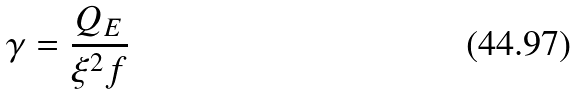Convert formula to latex. <formula><loc_0><loc_0><loc_500><loc_500>\gamma = \frac { Q _ { E } } { \xi ^ { 2 } f }</formula> 